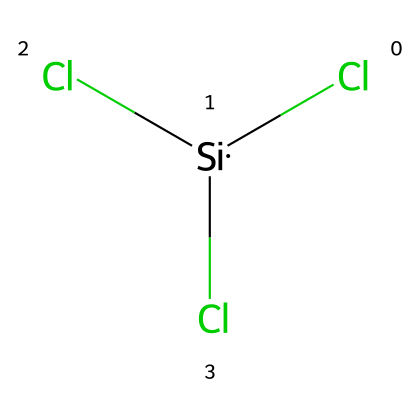What is the total number of chlorine atoms in trichlorosilane? The structural formula includes three chlorine atoms connected to the silicon atom. The notation "Cl" appears three times, indicating there are three chlorine atoms.
Answer: three What is the central atom in trichlorosilane? The central atom is indicated by the symbol "[Si]" in the SMILES representation, which refers to silicon, thus making it the main atom of the compound.
Answer: silicon How many bonds does silicon make in trichlorosilane? Silicon is bonded to three chlorine atoms, which are represented by the three "Cl" groups directly connected to the "[Si]" in the structure, indicating three single bonds.
Answer: three Is trichlorosilane a silane compound? The prefix "tri-" in trichlorosilane indicates it contains three chlorine atoms attached to silicon, which categorizes it under silanes, since silanes are compounds with a silicon central atom bonded to other atoms.
Answer: yes What type of compound is trichlorosilane classified as? Trichlorosilane contains silicon and halogens (chlorine), making it a silicon halide, which is a subclass of silanes due to the silicon atom present in the structure.
Answer: silicon halide What functional groups are present in trichlorosilane? The presence of the three chlorine atoms linked to silicon indicates that there are halogen functional groups in the compound. Since all three are chlorine, this is classified as a chloro group.
Answer: chloro groups Which chemical element in trichlorosilane is most electronegative? Chlorine is more electronegative than silicon, and since the compound features three chlorine atoms, it is the most electronegative element present in the structure.
Answer: chlorine 